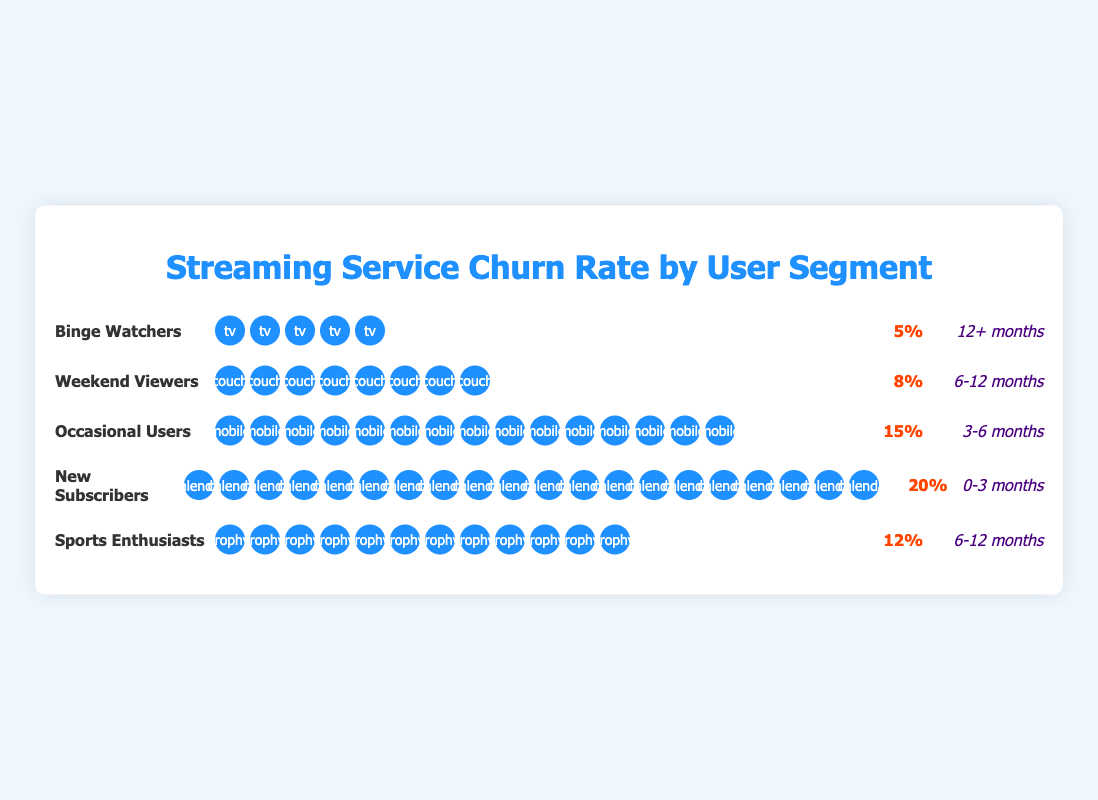What's the churn rate for 'Binge Watchers'? The figure displays the churn rate next to the segment name "Binge Watchers." Here we see that the churn rate for this segment is given as "5%".
Answer: 5% Which user segment has the highest churn rate? By comparing the churn rates of all segments listed, 'New Subscribers' has the highest churn rate at "20%".
Answer: New Subscribers What is the subscription duration for 'Sports Enthusiasts'? The figure lists the subscription duration for each segment. For 'Sports Enthusiasts,' it is "6-12 months".
Answer: 6-12 months Calculate the average churn rate for 'New Subscribers' and 'Occasional Users'. First, get the churn rates of 'New Subscribers' (20%) and 'Occasional Users' (15%). Then, compute the average: (20 + 15) / 2 = 17.5%.
Answer: 17.5% Which segment has a lower churn rate, 'Weekend Viewers' or 'Sports Enthusiasts'? Compare the churn rates: 'Weekend Viewers' have an 8% churn rate, and 'Sports Enthusiasts' have a 12% rate. Thus, 'Weekend Viewers' have a lower churn rate.
Answer: Weekend Viewers What segment has been subscribed for the longest duration, and what is that duration? 'Binge Watchers' have been subscribed for "12+ months," which is the longest duration listed in the figure.
Answer: Binge Watchers, 12+ months Add the churn rates of 'Binge Watchers,' 'Weekend Viewers,' and 'Sports Enthusiasts'. What is the result? Sum the churn rates: 5% (Binge Watchers) + 8% (Weekend Viewers) + 12% (Sports Enthusiasts) = 25%.
Answer: 25% Which user segment has the shortest subscription duration? 'New Subscribers' have the shortest subscription duration listed as "0-3 months".
Answer: New Subscribers Compare the churn rates of 'Binge Watchers' and 'Occasional Users'. Who has a higher churn rate and by how much? 'Binge Watchers' have a 5% churn rate whereas 'Occasional Users' have 15%. The difference is 15% - 5% = 10%.
Answer: Occasional Users, 10% How many icons are used to represent the churn rate for 'Weekend Viewers'? The churn rate for 'Weekend Viewers' is 8%, represented by 8 icons. Each icon represents 1% churn rate.
Answer: 8 icons 